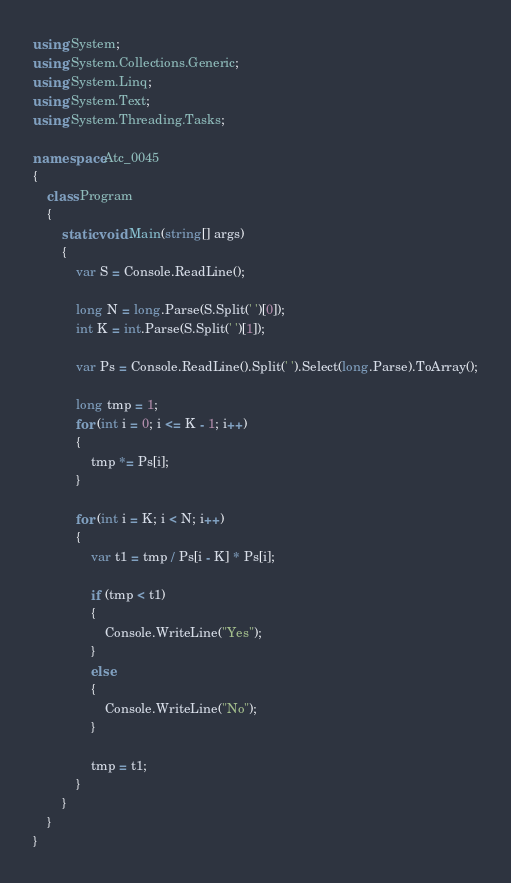<code> <loc_0><loc_0><loc_500><loc_500><_C#_>using System;
using System.Collections.Generic;
using System.Linq;
using System.Text;
using System.Threading.Tasks;

namespace Atc_0045
{
    class Program
    {
        static void Main(string[] args)
        {
            var S = Console.ReadLine();

            long N = long.Parse(S.Split(' ')[0]);
            int K = int.Parse(S.Split(' ')[1]);

            var Ps = Console.ReadLine().Split(' ').Select(long.Parse).ToArray();

            long tmp = 1;
            for (int i = 0; i <= K - 1; i++)
            {
                tmp *= Ps[i];
            }

            for (int i = K; i < N; i++)
            {
                var t1 = tmp / Ps[i - K] * Ps[i];

                if (tmp < t1)
                {
                    Console.WriteLine("Yes");
                }
                else
                {
                    Console.WriteLine("No");
                }

                tmp = t1;
            }
        }
    }
}
</code> 